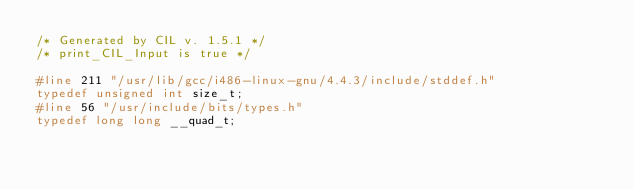<code> <loc_0><loc_0><loc_500><loc_500><_C_>/* Generated by CIL v. 1.5.1 */
/* print_CIL_Input is true */

#line 211 "/usr/lib/gcc/i486-linux-gnu/4.4.3/include/stddef.h"
typedef unsigned int size_t;
#line 56 "/usr/include/bits/types.h"
typedef long long __quad_t;</code> 